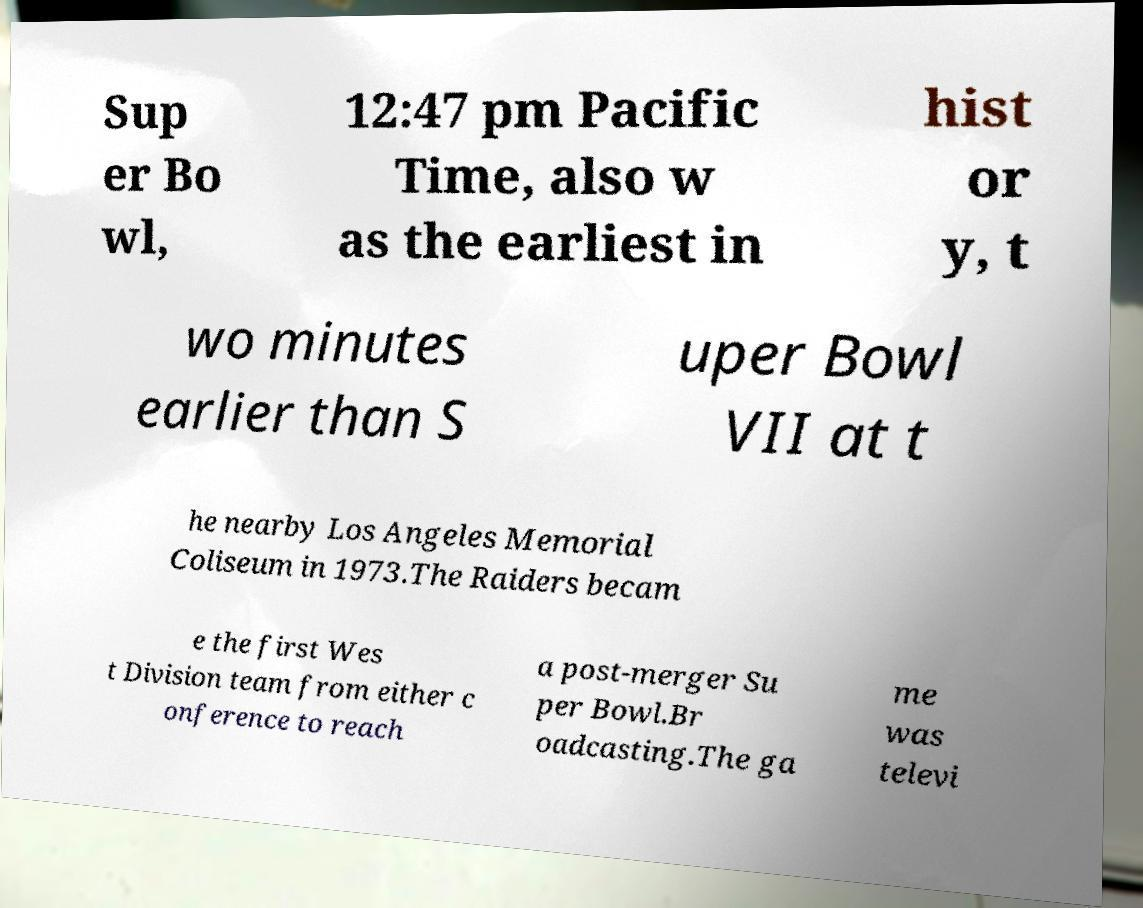Can you accurately transcribe the text from the provided image for me? Sup er Bo wl, 12:47 pm Pacific Time, also w as the earliest in hist or y, t wo minutes earlier than S uper Bowl VII at t he nearby Los Angeles Memorial Coliseum in 1973.The Raiders becam e the first Wes t Division team from either c onference to reach a post-merger Su per Bowl.Br oadcasting.The ga me was televi 